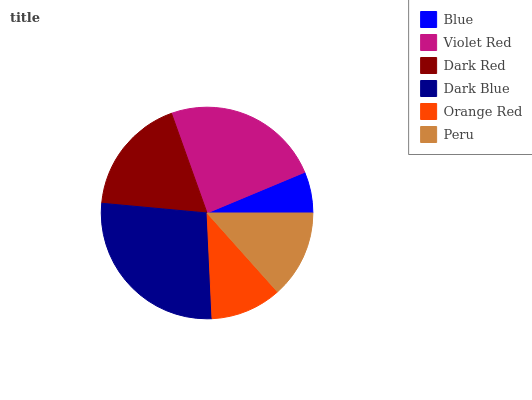Is Blue the minimum?
Answer yes or no. Yes. Is Dark Blue the maximum?
Answer yes or no. Yes. Is Violet Red the minimum?
Answer yes or no. No. Is Violet Red the maximum?
Answer yes or no. No. Is Violet Red greater than Blue?
Answer yes or no. Yes. Is Blue less than Violet Red?
Answer yes or no. Yes. Is Blue greater than Violet Red?
Answer yes or no. No. Is Violet Red less than Blue?
Answer yes or no. No. Is Dark Red the high median?
Answer yes or no. Yes. Is Peru the low median?
Answer yes or no. Yes. Is Blue the high median?
Answer yes or no. No. Is Dark Blue the low median?
Answer yes or no. No. 